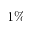Convert formula to latex. <formula><loc_0><loc_0><loc_500><loc_500>1 \%</formula> 